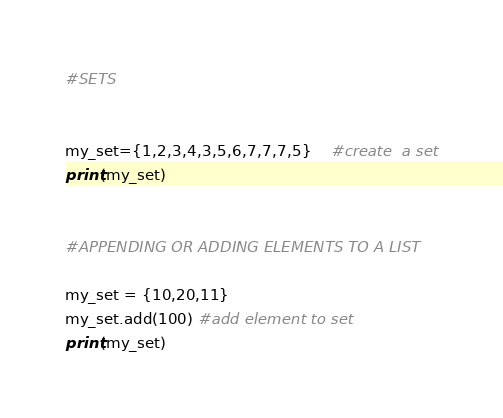Convert code to text. <code><loc_0><loc_0><loc_500><loc_500><_Python_>#SETS


my_set={1,2,3,4,3,5,6,7,7,7,5}    #create  a set
print(my_set)


#APPENDING OR ADDING ELEMENTS TO A LIST

my_set = {10,20,11}
my_set.add(100) #add element to set
print(my_set)

</code> 